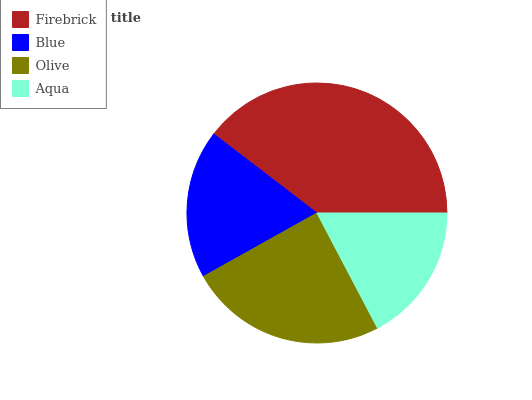Is Aqua the minimum?
Answer yes or no. Yes. Is Firebrick the maximum?
Answer yes or no. Yes. Is Blue the minimum?
Answer yes or no. No. Is Blue the maximum?
Answer yes or no. No. Is Firebrick greater than Blue?
Answer yes or no. Yes. Is Blue less than Firebrick?
Answer yes or no. Yes. Is Blue greater than Firebrick?
Answer yes or no. No. Is Firebrick less than Blue?
Answer yes or no. No. Is Olive the high median?
Answer yes or no. Yes. Is Blue the low median?
Answer yes or no. Yes. Is Blue the high median?
Answer yes or no. No. Is Aqua the low median?
Answer yes or no. No. 